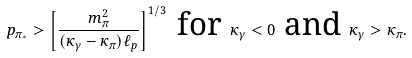<formula> <loc_0><loc_0><loc_500><loc_500>p _ { \pi _ { * } } > \left [ \frac { m _ { \pi } ^ { 2 } } { ( \kappa _ { \gamma } - \kappa _ { \pi } ) \ell _ { p } } \right ] ^ { 1 / 3 } \text { for } \kappa _ { \gamma } < 0 \text { and } \kappa _ { \gamma } > \kappa _ { \pi } .</formula> 